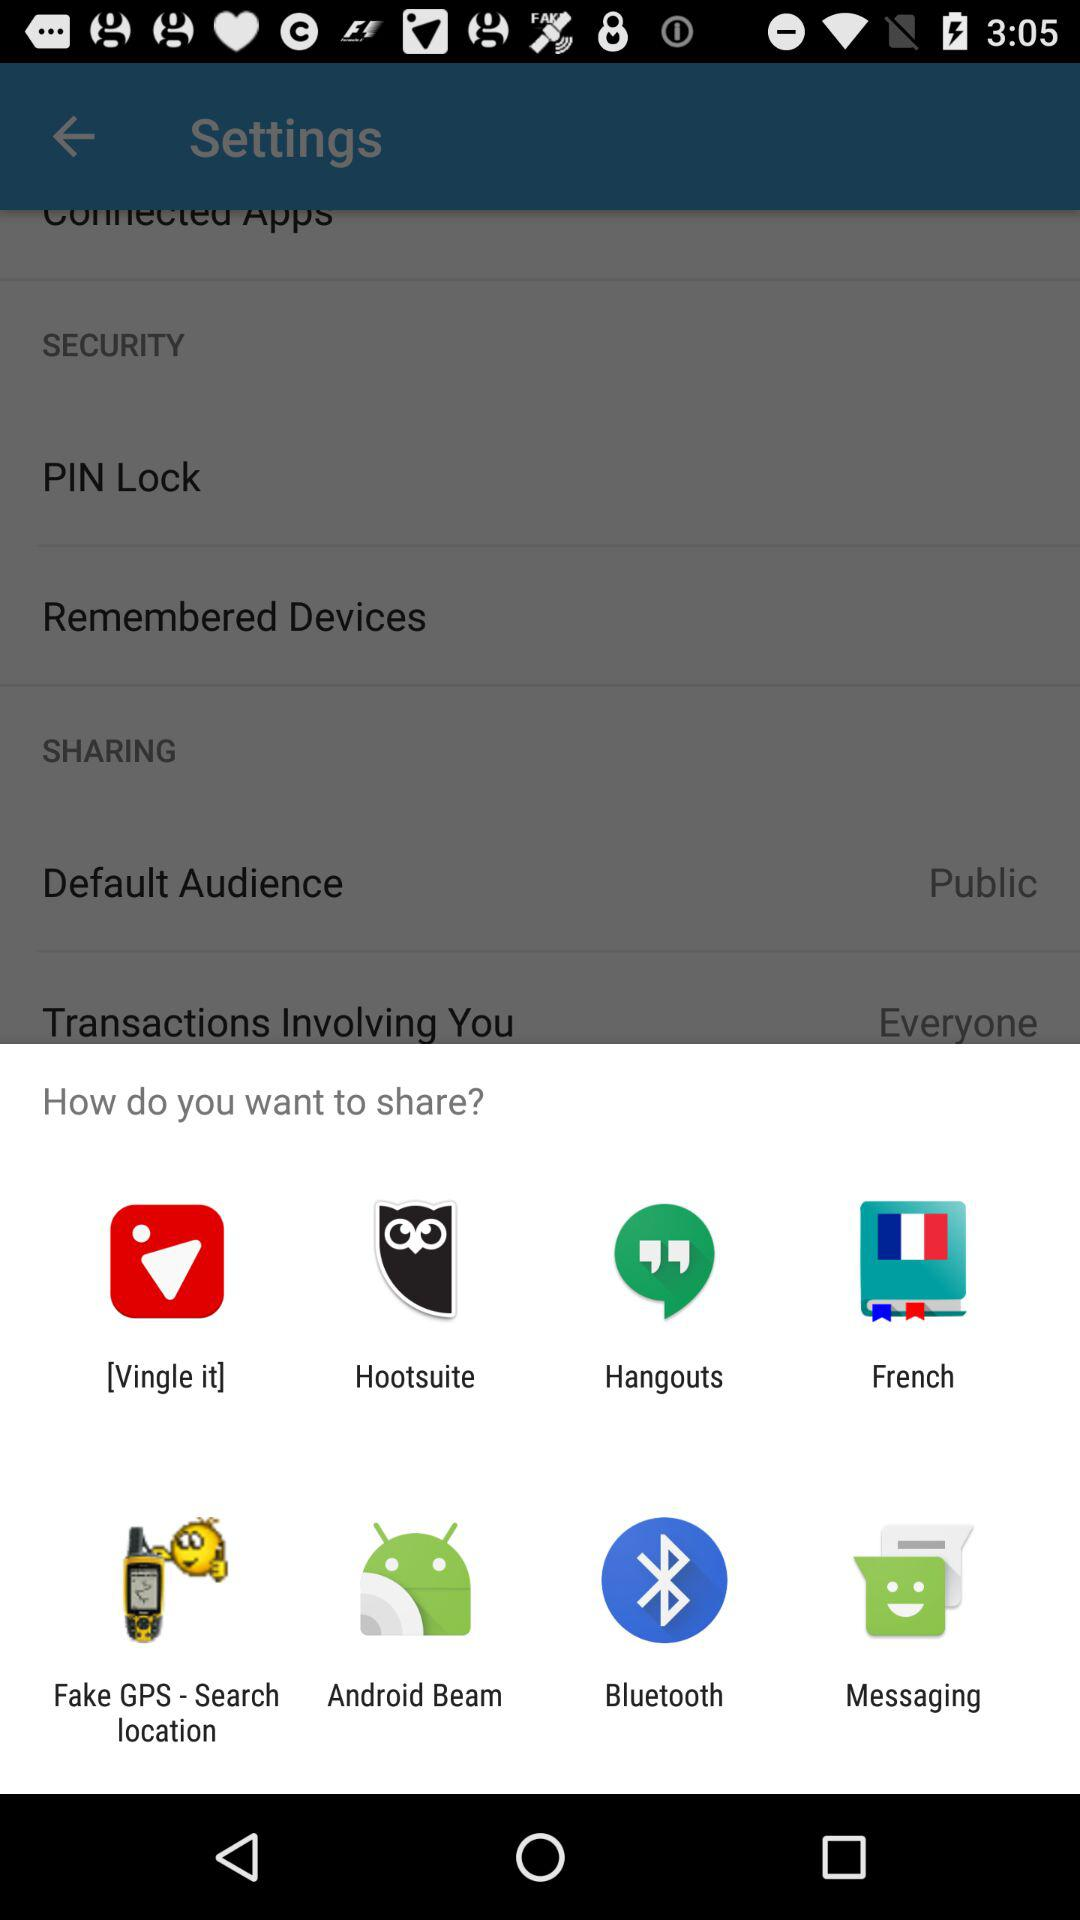Through which applications can we share? You can share through "[Vingle it]", "Hootsuite", "Hangouts", "French", "Fake GPS - Search location", "Android Beam", "Bluetooth" and "Messaging". 